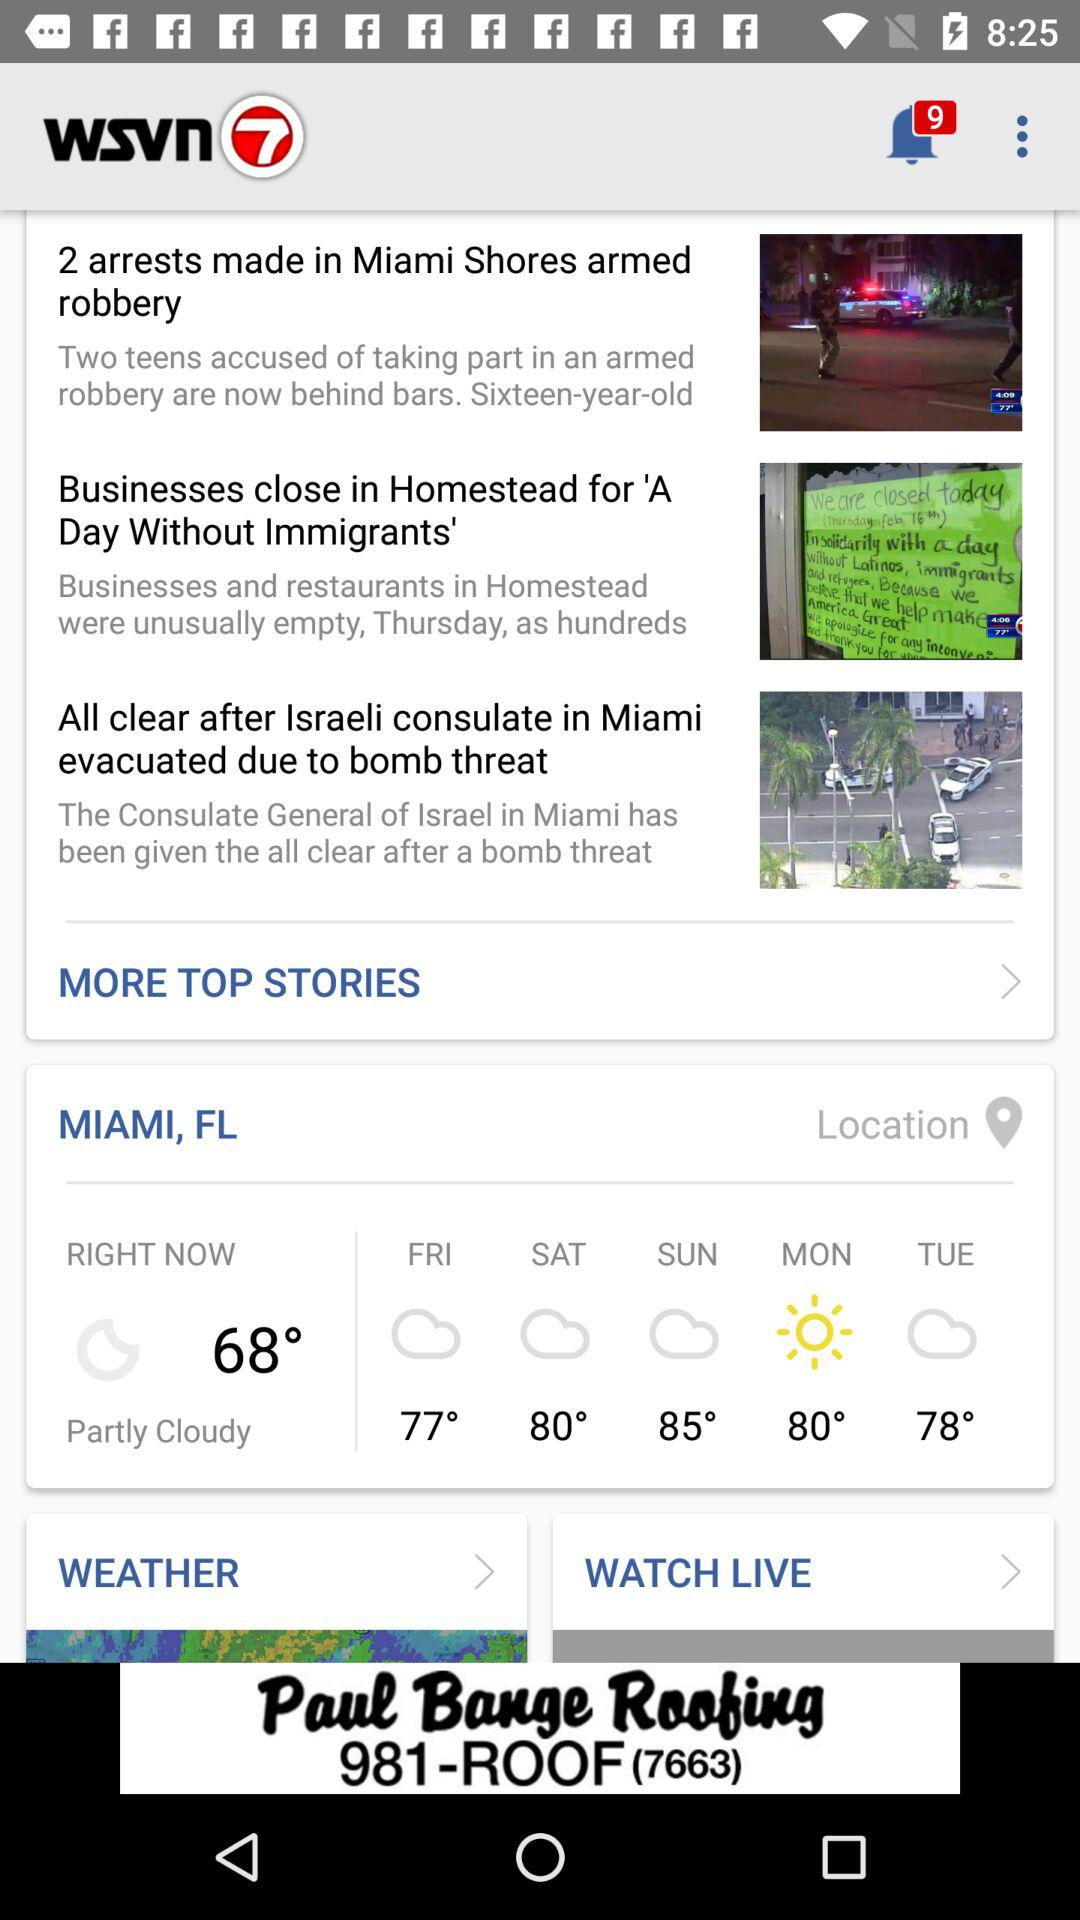What will the temperature be on Monday? The temperature on Monday will be 80 degrees. 